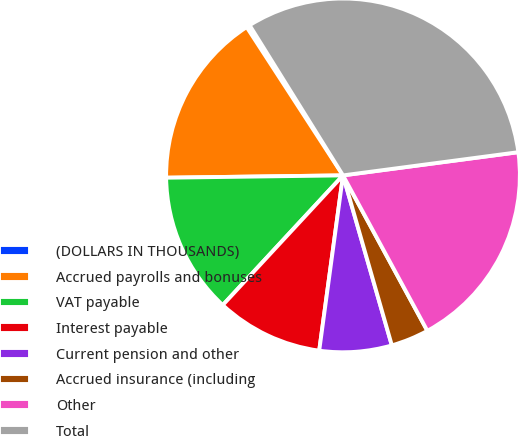<chart> <loc_0><loc_0><loc_500><loc_500><pie_chart><fcel>(DOLLARS IN THOUSANDS)<fcel>Accrued payrolls and bonuses<fcel>VAT payable<fcel>Interest payable<fcel>Current pension and other<fcel>Accrued insurance (including<fcel>Other<fcel>Total<nl><fcel>0.31%<fcel>16.04%<fcel>12.89%<fcel>9.75%<fcel>6.6%<fcel>3.46%<fcel>19.18%<fcel>31.76%<nl></chart> 